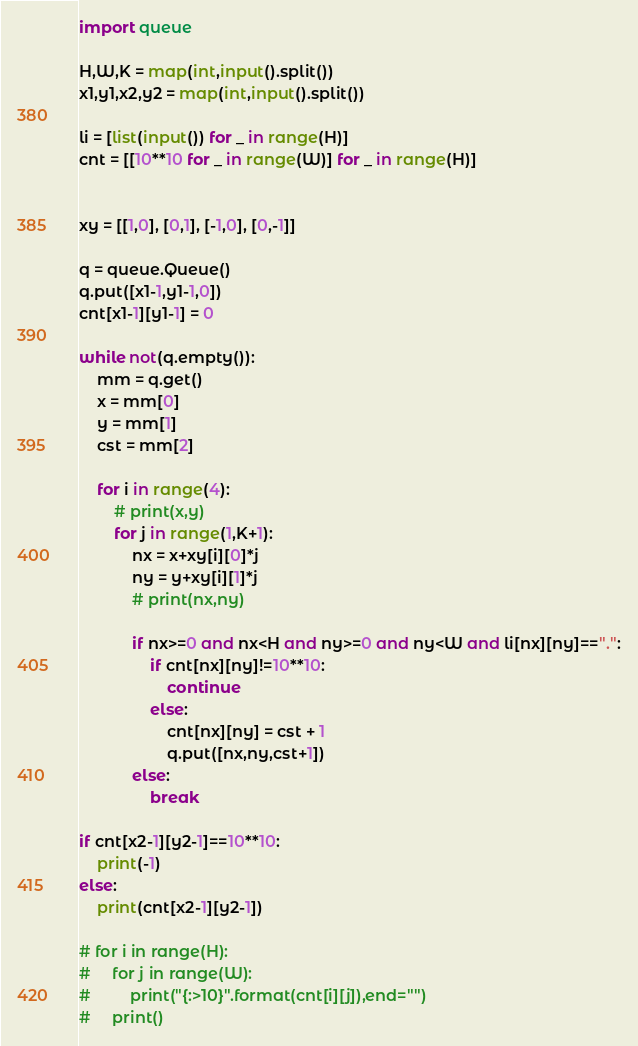<code> <loc_0><loc_0><loc_500><loc_500><_Python_>import queue

H,W,K = map(int,input().split())
x1,y1,x2,y2 = map(int,input().split())

li = [list(input()) for _ in range(H)]
cnt = [[10**10 for _ in range(W)] for _ in range(H)]


xy = [[1,0], [0,1], [-1,0], [0,-1]]

q = queue.Queue()
q.put([x1-1,y1-1,0])
cnt[x1-1][y1-1] = 0

while not(q.empty()):
    mm = q.get()
    x = mm[0]
    y = mm[1]
    cst = mm[2]

    for i in range(4):
        # print(x,y)
        for j in range(1,K+1):
            nx = x+xy[i][0]*j
            ny = y+xy[i][1]*j
            # print(nx,ny)
            
            if nx>=0 and nx<H and ny>=0 and ny<W and li[nx][ny]==".":
                if cnt[nx][ny]!=10**10:
                    continue
                else:
                    cnt[nx][ny] = cst + 1
                    q.put([nx,ny,cst+1])
            else:
                break

if cnt[x2-1][y2-1]==10**10:
    print(-1)
else:
    print(cnt[x2-1][y2-1])

# for i in range(H):
#     for j in range(W):
#         print("{:>10}".format(cnt[i][j]),end="")
#     print()



</code> 